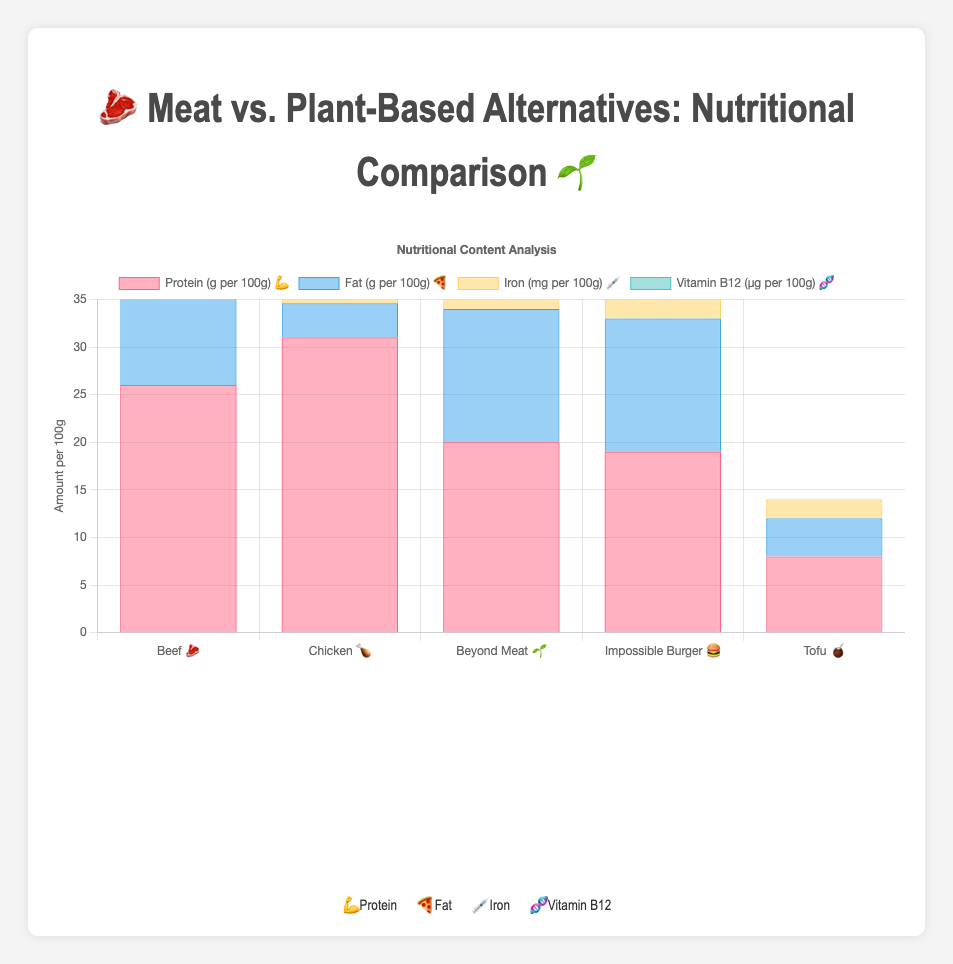What food product has the highest protein content? The highest protein content is determined by looking at the dataset where Beef 🥩 has 26g per 100g and Chicken 🍗 has 31g per 100g. Chicken has the highest protein content.
Answer: Chicken 🍗 Which product has the lowest fat content? The fat content is compared among all products, with Chicken 🍗 having 3.6g, which is the lowest among the options.
Answer: Chicken 🍗 How does the iron content of Beyond Meat 🌱 compare to Beef 🥩? Beyond Meat 🌱 has 5.8mg of iron, while Beef 🥩 has 2.7mg. Therefore, Beyond Meat has a higher iron content.
Answer: Beyond Meat 🌱 Rank the products based on their Vitamin B12 content. The Vitamin B12 contents are compared: Beef 🥩 (2.1 μg), Chicken 🍗 (0.3 μg), Beyond Meat 🌱 (2.4 μg), Impossible Burger 🍔 (3.0 μg), and Tofu 🧉 (0 μg). The ranking from highest to lowest is Impossible Burger 🍔, Beyond Meat 🌱, Beef 🥩, Chicken 🍗, and Tofu 🧉.
Answer: Impossible Burger > Beyond Meat > Beef > Chicken > Tofu What is the average fat content across all products? The average fat content is calculated by summing the fat contents (17 + 3.6 + 14 + 14 + 4) and dividing by the number of products (5): (52.6 / 5) = 10.52g.
Answer: 10.52g Comparing plant-based alternatives, which has more protein: Beyond Meat 🌱 or Impossible Burger 🍔? Beyond Meat 🌱 has 20g of protein, while Impossible Burger 🍔 has 19g of protein. Beyond Meat has more protein.
Answer: Beyond Meat 🌱 What is the difference in iron content between Tofu 🧉 and Chicken 🍗? Tofu 🧉 has 2.0mg of iron, and Chicken 🍗 has 1.3mg of iron. The difference is 2.0 - 1.3 = 0.7mg.
Answer: 0.7mg What is the total Vitamin B12 content if you consume 100g of both Beef 🥩 and Beyond Meat 🌱? The Vitamin B12 content for Beef 🥩 is 2.1 μg, and for Beyond Meat 🌱 is 2.4 μg. The total is 2.1 + 2.4 = 4.5 μg.
Answer: 4.5 μg Compare the total content of all the measured nutrients in Chicken 🍗 with those in Tofu 🧉. Which is higher overall? For Chicken 🍗: Protein 31g, Fat 3.6g, Iron 1.3mg, Vitamin B12 0.3μg. For Tofu 🧉: Protein 8g, Fat 4g, Iron 2mg, Vitamin B12 0μg. Total content comparison: Chicken (31 + 3.6 + 1.3 + 0.3 = 36.2) vs. Tofu (8 + 4 + 2 = 14). Chicken has a higher overall content.
Answer: Chicken 🍗 